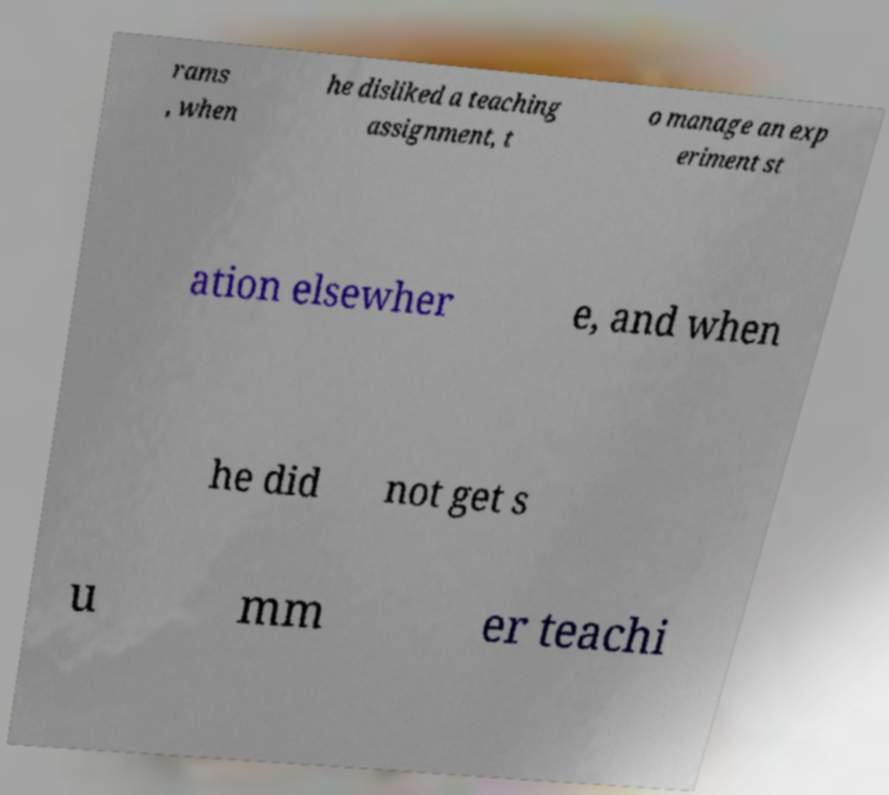Could you extract and type out the text from this image? rams , when he disliked a teaching assignment, t o manage an exp eriment st ation elsewher e, and when he did not get s u mm er teachi 